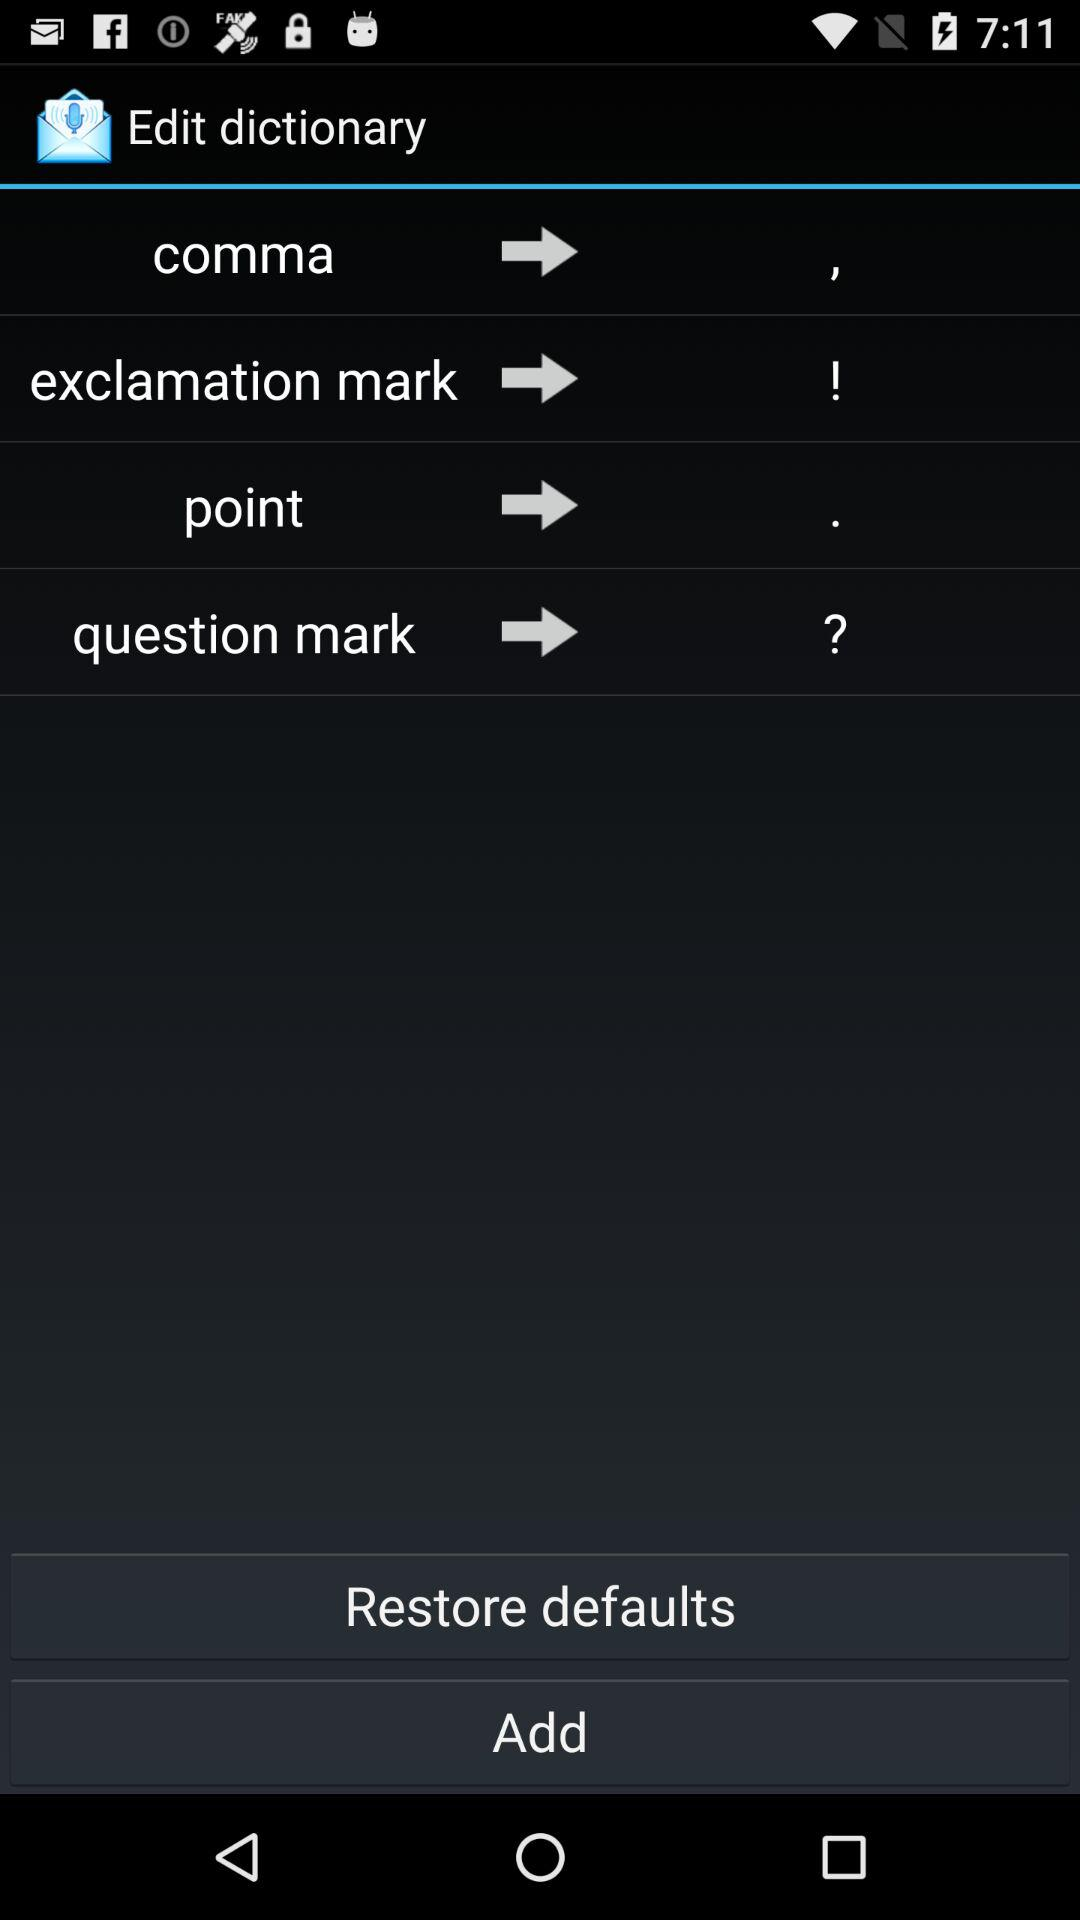Who is this application powered by?
When the provided information is insufficient, respond with <no answer>. <no answer> 